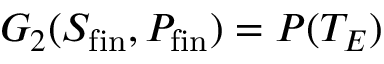Convert formula to latex. <formula><loc_0><loc_0><loc_500><loc_500>G _ { 2 } ( S _ { f i n } , P _ { f i n } ) = P ( T _ { E } )</formula> 